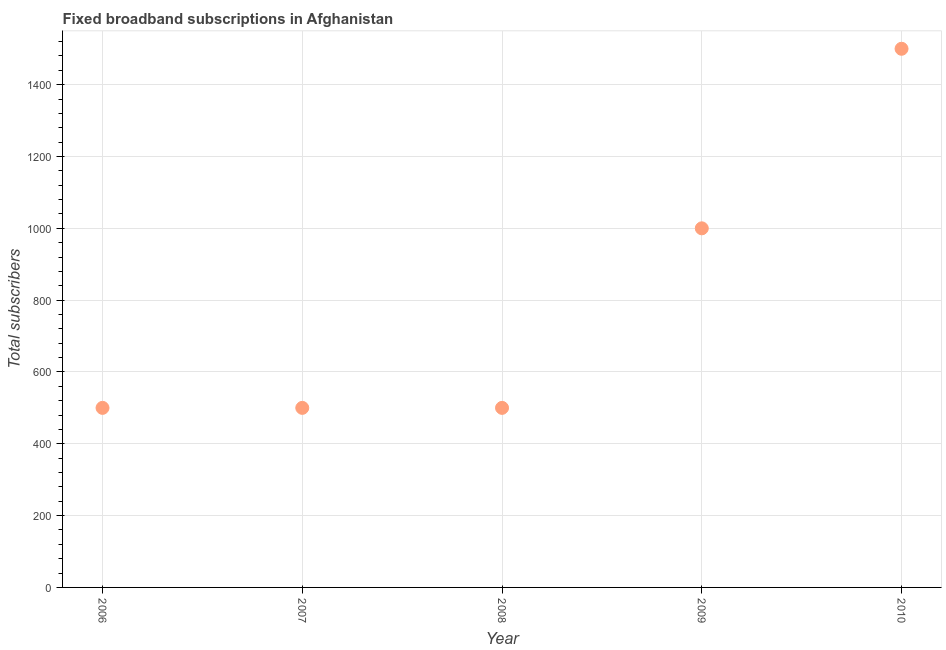What is the total number of fixed broadband subscriptions in 2007?
Provide a short and direct response. 500. Across all years, what is the maximum total number of fixed broadband subscriptions?
Your answer should be very brief. 1500. Across all years, what is the minimum total number of fixed broadband subscriptions?
Make the answer very short. 500. What is the sum of the total number of fixed broadband subscriptions?
Your response must be concise. 4000. What is the difference between the total number of fixed broadband subscriptions in 2006 and 2009?
Keep it short and to the point. -500. What is the average total number of fixed broadband subscriptions per year?
Your answer should be very brief. 800. What is the median total number of fixed broadband subscriptions?
Offer a very short reply. 500. Is the total number of fixed broadband subscriptions in 2007 less than that in 2008?
Make the answer very short. No. Is the sum of the total number of fixed broadband subscriptions in 2007 and 2010 greater than the maximum total number of fixed broadband subscriptions across all years?
Offer a very short reply. Yes. What is the difference between the highest and the lowest total number of fixed broadband subscriptions?
Offer a terse response. 1000. How many dotlines are there?
Make the answer very short. 1. How many years are there in the graph?
Your answer should be compact. 5. What is the difference between two consecutive major ticks on the Y-axis?
Offer a very short reply. 200. Does the graph contain any zero values?
Make the answer very short. No. What is the title of the graph?
Give a very brief answer. Fixed broadband subscriptions in Afghanistan. What is the label or title of the Y-axis?
Your response must be concise. Total subscribers. What is the Total subscribers in 2010?
Your answer should be very brief. 1500. What is the difference between the Total subscribers in 2006 and 2007?
Make the answer very short. 0. What is the difference between the Total subscribers in 2006 and 2008?
Provide a short and direct response. 0. What is the difference between the Total subscribers in 2006 and 2009?
Your answer should be compact. -500. What is the difference between the Total subscribers in 2006 and 2010?
Ensure brevity in your answer.  -1000. What is the difference between the Total subscribers in 2007 and 2009?
Provide a short and direct response. -500. What is the difference between the Total subscribers in 2007 and 2010?
Your response must be concise. -1000. What is the difference between the Total subscribers in 2008 and 2009?
Keep it short and to the point. -500. What is the difference between the Total subscribers in 2008 and 2010?
Provide a succinct answer. -1000. What is the difference between the Total subscribers in 2009 and 2010?
Your answer should be compact. -500. What is the ratio of the Total subscribers in 2006 to that in 2010?
Provide a short and direct response. 0.33. What is the ratio of the Total subscribers in 2007 to that in 2008?
Ensure brevity in your answer.  1. What is the ratio of the Total subscribers in 2007 to that in 2009?
Provide a succinct answer. 0.5. What is the ratio of the Total subscribers in 2007 to that in 2010?
Make the answer very short. 0.33. What is the ratio of the Total subscribers in 2008 to that in 2010?
Give a very brief answer. 0.33. What is the ratio of the Total subscribers in 2009 to that in 2010?
Your response must be concise. 0.67. 